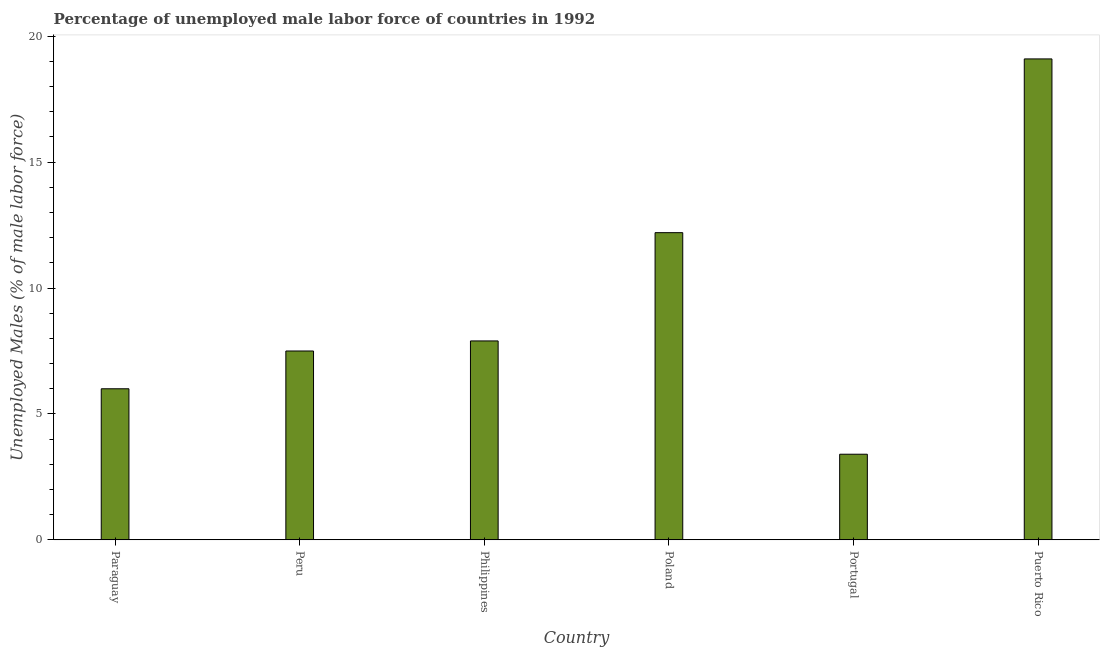Does the graph contain any zero values?
Offer a terse response. No. Does the graph contain grids?
Your answer should be very brief. No. What is the title of the graph?
Keep it short and to the point. Percentage of unemployed male labor force of countries in 1992. What is the label or title of the X-axis?
Ensure brevity in your answer.  Country. What is the label or title of the Y-axis?
Your answer should be very brief. Unemployed Males (% of male labor force). What is the total unemployed male labour force in Philippines?
Your answer should be compact. 7.9. Across all countries, what is the maximum total unemployed male labour force?
Keep it short and to the point. 19.1. Across all countries, what is the minimum total unemployed male labour force?
Make the answer very short. 3.4. In which country was the total unemployed male labour force maximum?
Provide a succinct answer. Puerto Rico. In which country was the total unemployed male labour force minimum?
Offer a terse response. Portugal. What is the sum of the total unemployed male labour force?
Your response must be concise. 56.1. What is the average total unemployed male labour force per country?
Make the answer very short. 9.35. What is the median total unemployed male labour force?
Provide a short and direct response. 7.7. In how many countries, is the total unemployed male labour force greater than 18 %?
Offer a terse response. 1. What is the ratio of the total unemployed male labour force in Paraguay to that in Poland?
Offer a terse response. 0.49. What is the difference between the highest and the second highest total unemployed male labour force?
Offer a very short reply. 6.9. Is the sum of the total unemployed male labour force in Paraguay and Philippines greater than the maximum total unemployed male labour force across all countries?
Your response must be concise. No. What is the difference between the highest and the lowest total unemployed male labour force?
Offer a terse response. 15.7. In how many countries, is the total unemployed male labour force greater than the average total unemployed male labour force taken over all countries?
Ensure brevity in your answer.  2. How many bars are there?
Offer a very short reply. 6. Are all the bars in the graph horizontal?
Provide a short and direct response. No. How many countries are there in the graph?
Your response must be concise. 6. What is the difference between two consecutive major ticks on the Y-axis?
Provide a succinct answer. 5. Are the values on the major ticks of Y-axis written in scientific E-notation?
Your answer should be very brief. No. What is the Unemployed Males (% of male labor force) of Paraguay?
Make the answer very short. 6. What is the Unemployed Males (% of male labor force) of Peru?
Your answer should be compact. 7.5. What is the Unemployed Males (% of male labor force) in Philippines?
Ensure brevity in your answer.  7.9. What is the Unemployed Males (% of male labor force) in Poland?
Keep it short and to the point. 12.2. What is the Unemployed Males (% of male labor force) of Portugal?
Give a very brief answer. 3.4. What is the Unemployed Males (% of male labor force) of Puerto Rico?
Your response must be concise. 19.1. What is the difference between the Unemployed Males (% of male labor force) in Paraguay and Peru?
Offer a terse response. -1.5. What is the difference between the Unemployed Males (% of male labor force) in Paraguay and Portugal?
Ensure brevity in your answer.  2.6. What is the difference between the Unemployed Males (% of male labor force) in Paraguay and Puerto Rico?
Give a very brief answer. -13.1. What is the difference between the Unemployed Males (% of male labor force) in Peru and Portugal?
Provide a succinct answer. 4.1. What is the difference between the Unemployed Males (% of male labor force) in Peru and Puerto Rico?
Give a very brief answer. -11.6. What is the difference between the Unemployed Males (% of male labor force) in Philippines and Poland?
Provide a short and direct response. -4.3. What is the difference between the Unemployed Males (% of male labor force) in Philippines and Portugal?
Ensure brevity in your answer.  4.5. What is the difference between the Unemployed Males (% of male labor force) in Poland and Puerto Rico?
Keep it short and to the point. -6.9. What is the difference between the Unemployed Males (% of male labor force) in Portugal and Puerto Rico?
Your answer should be compact. -15.7. What is the ratio of the Unemployed Males (% of male labor force) in Paraguay to that in Peru?
Make the answer very short. 0.8. What is the ratio of the Unemployed Males (% of male labor force) in Paraguay to that in Philippines?
Ensure brevity in your answer.  0.76. What is the ratio of the Unemployed Males (% of male labor force) in Paraguay to that in Poland?
Offer a very short reply. 0.49. What is the ratio of the Unemployed Males (% of male labor force) in Paraguay to that in Portugal?
Your answer should be very brief. 1.76. What is the ratio of the Unemployed Males (% of male labor force) in Paraguay to that in Puerto Rico?
Offer a terse response. 0.31. What is the ratio of the Unemployed Males (% of male labor force) in Peru to that in Philippines?
Provide a succinct answer. 0.95. What is the ratio of the Unemployed Males (% of male labor force) in Peru to that in Poland?
Provide a short and direct response. 0.61. What is the ratio of the Unemployed Males (% of male labor force) in Peru to that in Portugal?
Ensure brevity in your answer.  2.21. What is the ratio of the Unemployed Males (% of male labor force) in Peru to that in Puerto Rico?
Your answer should be compact. 0.39. What is the ratio of the Unemployed Males (% of male labor force) in Philippines to that in Poland?
Offer a very short reply. 0.65. What is the ratio of the Unemployed Males (% of male labor force) in Philippines to that in Portugal?
Make the answer very short. 2.32. What is the ratio of the Unemployed Males (% of male labor force) in Philippines to that in Puerto Rico?
Your answer should be very brief. 0.41. What is the ratio of the Unemployed Males (% of male labor force) in Poland to that in Portugal?
Offer a terse response. 3.59. What is the ratio of the Unemployed Males (% of male labor force) in Poland to that in Puerto Rico?
Offer a very short reply. 0.64. What is the ratio of the Unemployed Males (% of male labor force) in Portugal to that in Puerto Rico?
Give a very brief answer. 0.18. 